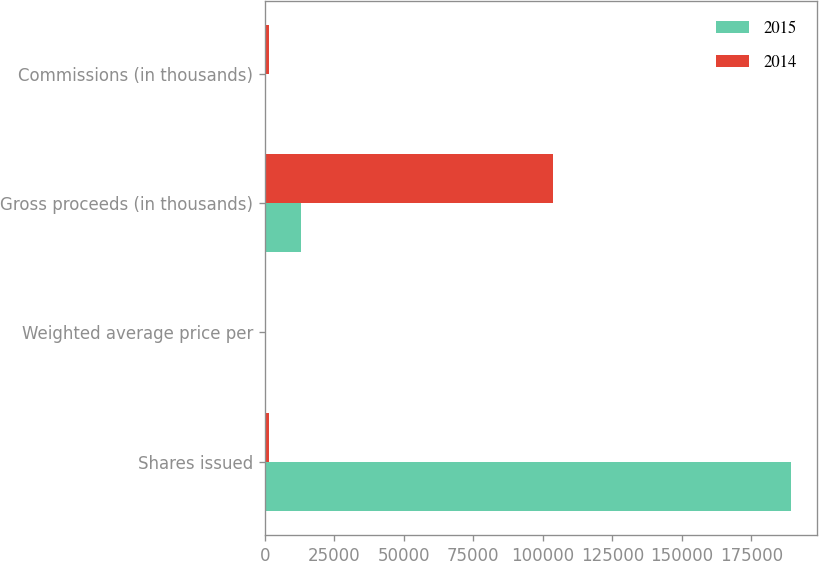<chart> <loc_0><loc_0><loc_500><loc_500><stacked_bar_chart><ecel><fcel>Shares issued<fcel>Weighted average price per<fcel>Gross proceeds (in thousands)<fcel>Commissions (in thousands)<nl><fcel>2015<fcel>189266<fcel>67.86<fcel>12843<fcel>161<nl><fcel>2014<fcel>1369<fcel>60<fcel>103821<fcel>1369<nl></chart> 